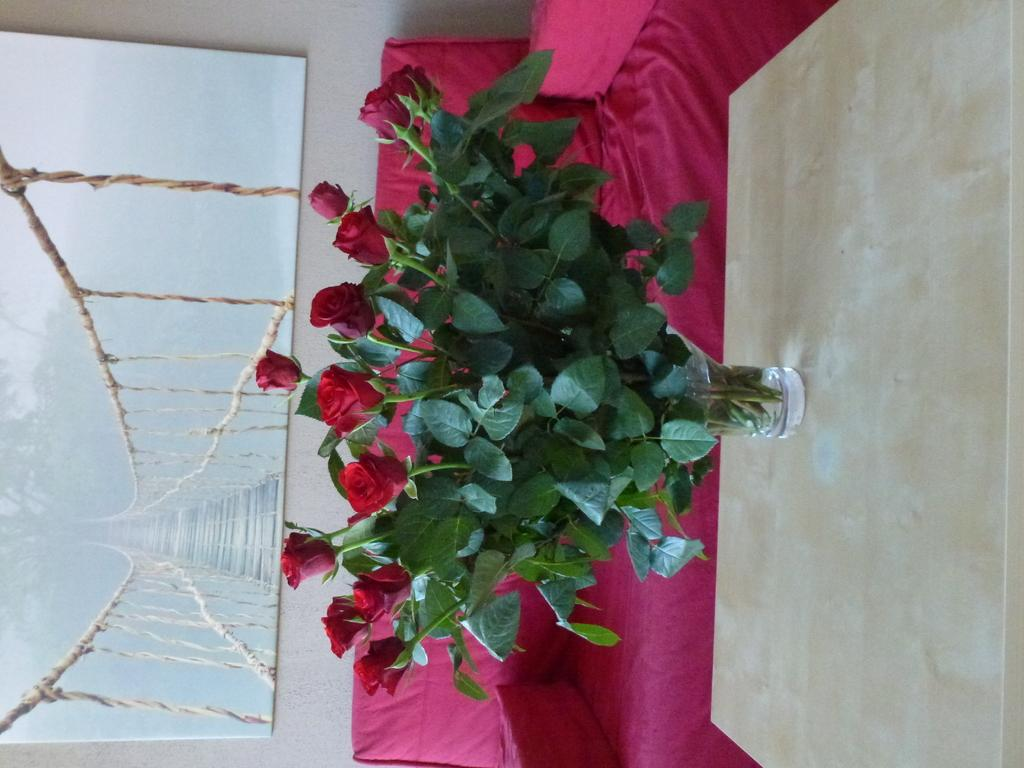What is on the table in the image? There is a flower vase on the table. What can be seen in the background of the image? There is a sofa and a photo frame on the wall in the background. What type of net is being used to catch ideas in the image? There is no net or any reference to catching ideas in the image. 